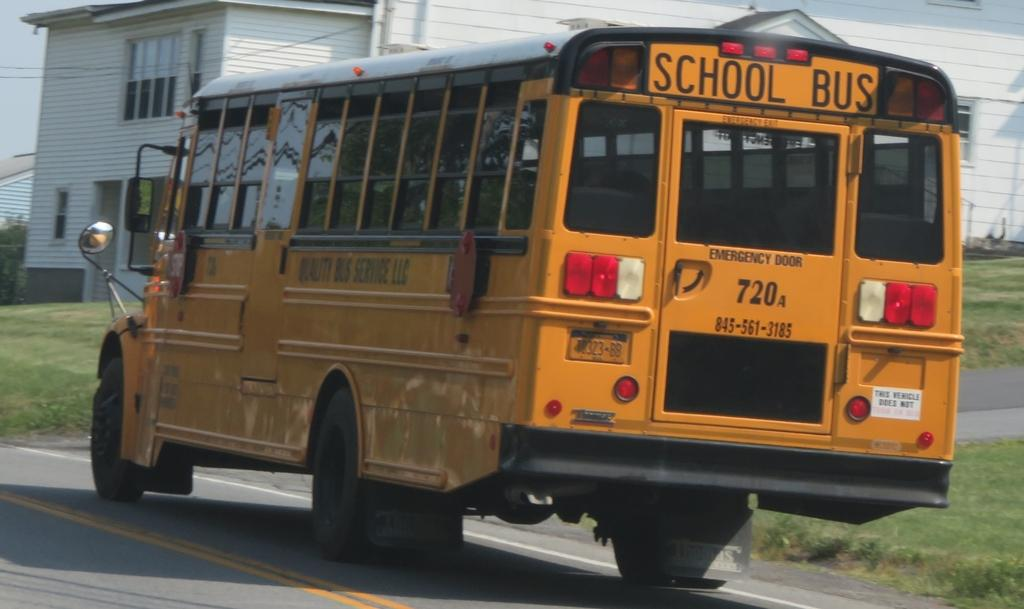What type of vehicle is in the image? There is a yellow school bus in the image. What is the school bus doing in the image? The school bus is moving on the road. What can be seen in the background of the image? There is a house in the background of the image. What is the color of the house in the image? The house is white in color. What type of cake is being served at the end of the road in the image? There is no cake or indication of an event in the image; it simply shows a yellow school bus moving on the road and a white house in the background. 